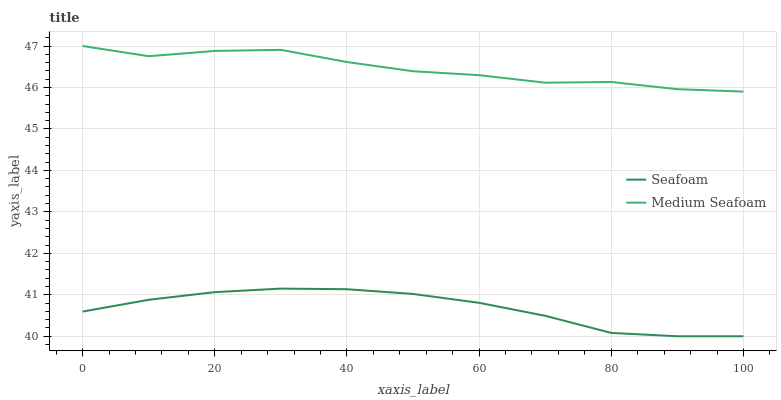Does Seafoam have the minimum area under the curve?
Answer yes or no. Yes. Does Medium Seafoam have the maximum area under the curve?
Answer yes or no. Yes. Does Medium Seafoam have the minimum area under the curve?
Answer yes or no. No. Is Seafoam the smoothest?
Answer yes or no. Yes. Is Medium Seafoam the roughest?
Answer yes or no. Yes. Is Medium Seafoam the smoothest?
Answer yes or no. No. Does Medium Seafoam have the lowest value?
Answer yes or no. No. Does Medium Seafoam have the highest value?
Answer yes or no. Yes. Is Seafoam less than Medium Seafoam?
Answer yes or no. Yes. Is Medium Seafoam greater than Seafoam?
Answer yes or no. Yes. Does Seafoam intersect Medium Seafoam?
Answer yes or no. No. 